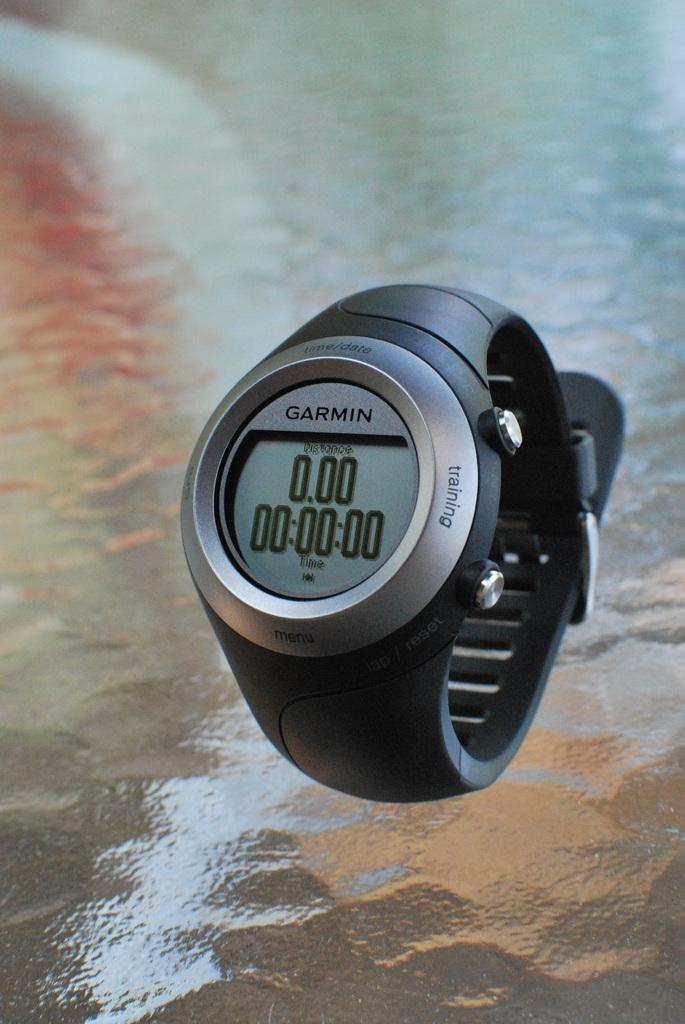Provide a one-sentence caption for the provided image. The Garmin watch has a black wrist band. 